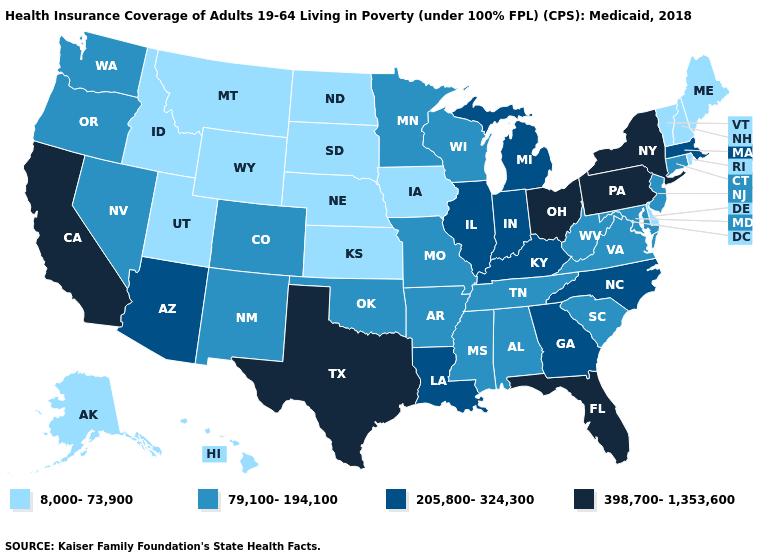Which states have the lowest value in the USA?
Answer briefly. Alaska, Delaware, Hawaii, Idaho, Iowa, Kansas, Maine, Montana, Nebraska, New Hampshire, North Dakota, Rhode Island, South Dakota, Utah, Vermont, Wyoming. Which states have the highest value in the USA?
Be succinct. California, Florida, New York, Ohio, Pennsylvania, Texas. Is the legend a continuous bar?
Answer briefly. No. Among the states that border Massachusetts , does New York have the highest value?
Quick response, please. Yes. Name the states that have a value in the range 398,700-1,353,600?
Keep it brief. California, Florida, New York, Ohio, Pennsylvania, Texas. What is the highest value in states that border California?
Quick response, please. 205,800-324,300. Name the states that have a value in the range 79,100-194,100?
Short answer required. Alabama, Arkansas, Colorado, Connecticut, Maryland, Minnesota, Mississippi, Missouri, Nevada, New Jersey, New Mexico, Oklahoma, Oregon, South Carolina, Tennessee, Virginia, Washington, West Virginia, Wisconsin. Among the states that border New Hampshire , which have the lowest value?
Concise answer only. Maine, Vermont. Name the states that have a value in the range 79,100-194,100?
Be succinct. Alabama, Arkansas, Colorado, Connecticut, Maryland, Minnesota, Mississippi, Missouri, Nevada, New Jersey, New Mexico, Oklahoma, Oregon, South Carolina, Tennessee, Virginia, Washington, West Virginia, Wisconsin. What is the value of Louisiana?
Write a very short answer. 205,800-324,300. What is the highest value in states that border West Virginia?
Short answer required. 398,700-1,353,600. Which states have the lowest value in the South?
Quick response, please. Delaware. Does Ohio have the same value as Colorado?
Keep it brief. No. Does Wyoming have a lower value than Pennsylvania?
Concise answer only. Yes. Does Missouri have a lower value than Oklahoma?
Give a very brief answer. No. 